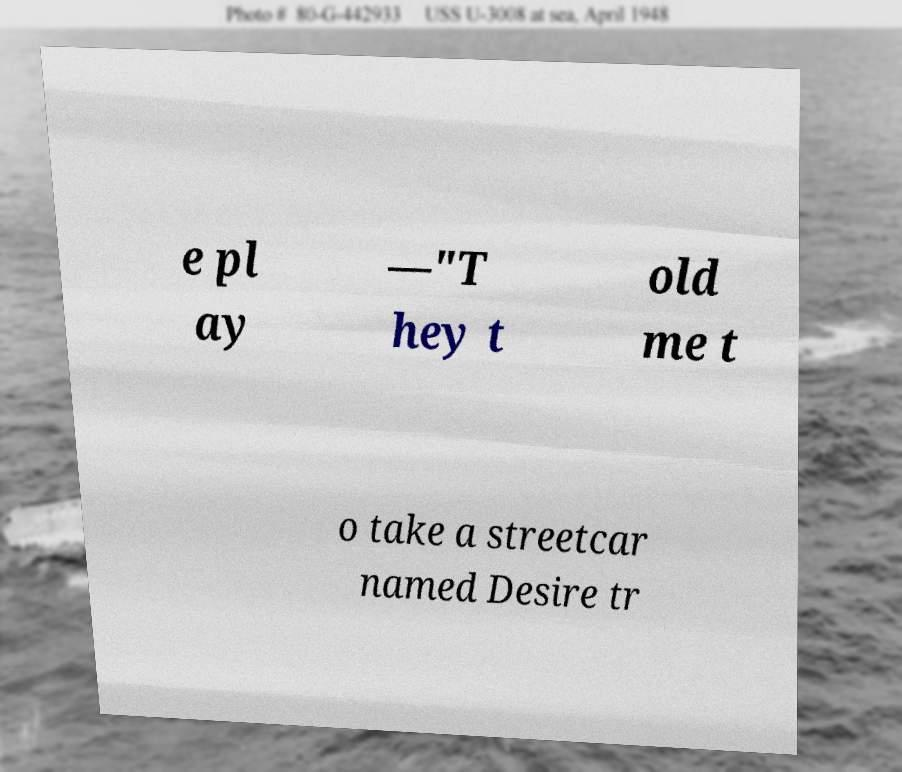Can you read and provide the text displayed in the image?This photo seems to have some interesting text. Can you extract and type it out for me? e pl ay —"T hey t old me t o take a streetcar named Desire tr 